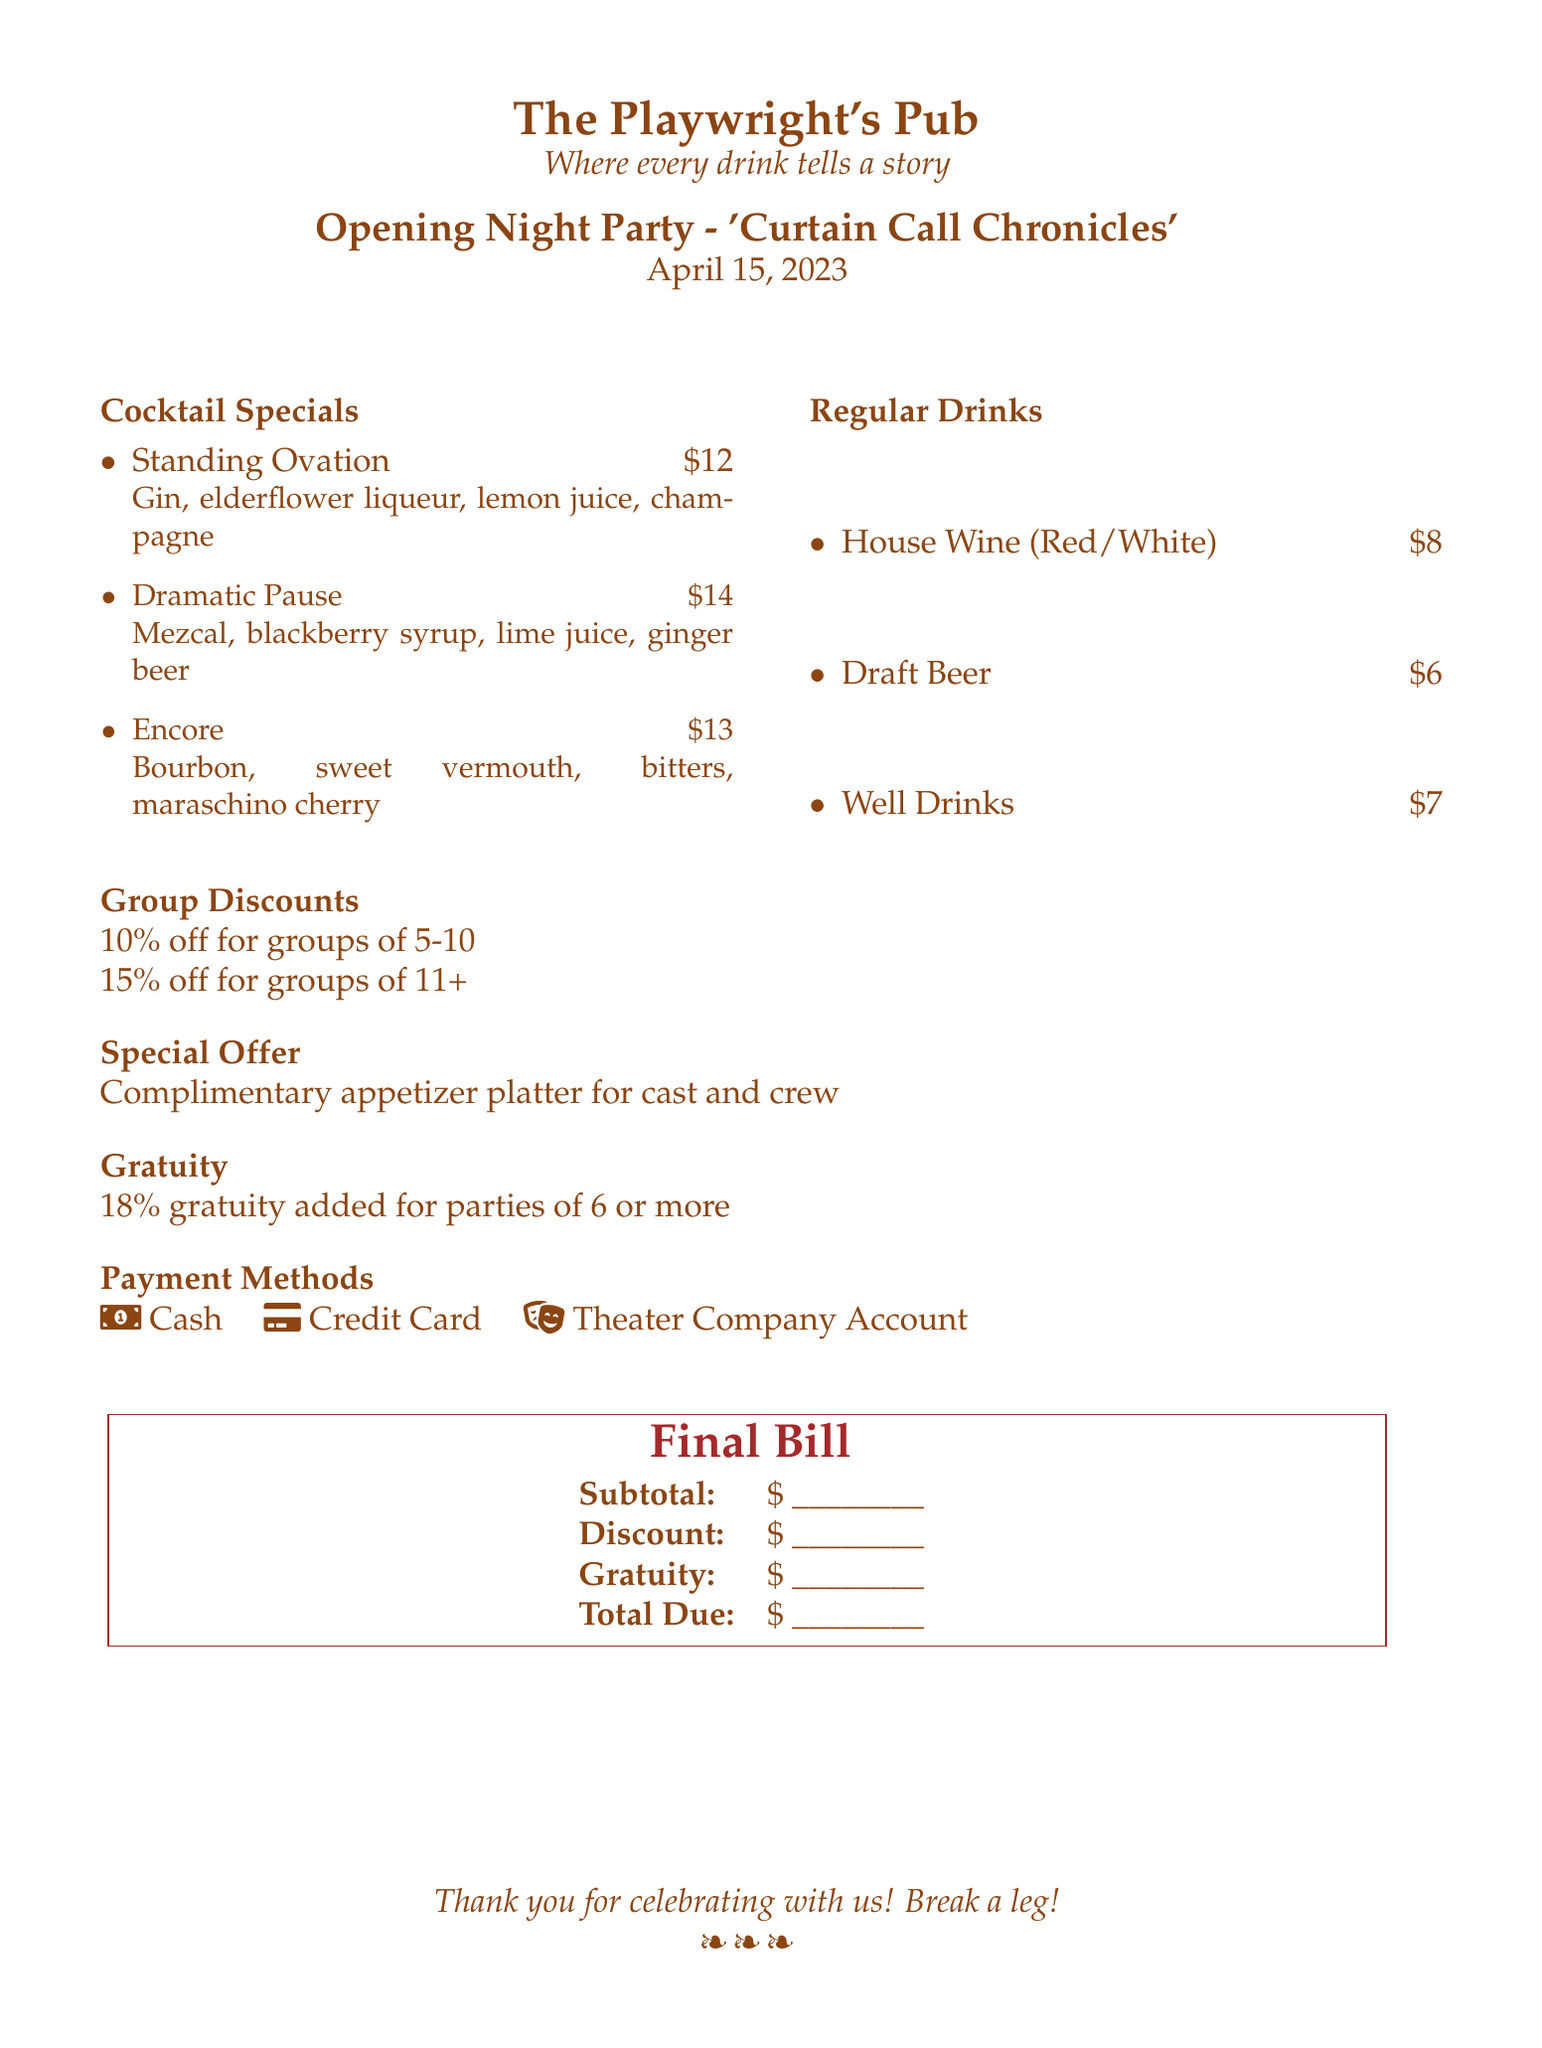What is the date of the opening night party? The date of the opening night party is explicitly stated in the document as April 15, 2023.
Answer: April 15, 2023 What are the cocktail specials? The document lists the cocktail specials, which include "Standing Ovation," "Dramatic Pause," and "Encore."
Answer: Standing Ovation, Dramatic Pause, Encore What is the discount for a group of 5-10? The document mentions a discount specifically for groups of 5-10 individuals as 10%.
Answer: 10% What is the price of the "Dramatic Pause" cocktail? The document provides the price of "Dramatic Pause," indicating it costs $14.
Answer: $14 What is added for gratuity for parties of 6 or more? According to the document, an 18% gratuity is added for parties of 6 or more, as stated.
Answer: 18% What special offer is available for the cast and crew? The document states that there is a complimentary appetizer platter for the cast and crew.
Answer: Complimentary appetizer platter What is the total due field for the final bill? The final bill document includes a space for the total due, indicating it should be filled out with a dollar amount.
Answer: \$ ________ How many types of payment methods are mentioned? The document lists three payment methods available for the event, specifically indicated under "Payment Methods."
Answer: Three 